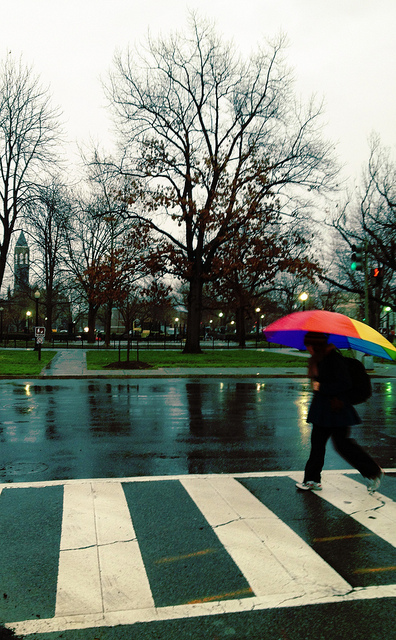<image>What intersection is this crosswalk at? It is unknown what intersection this crosswalk is at. It could be at Pennsylvania, at a park, or 10th Avenue. What intersection is this crosswalk at? It is unclear what intersection this crosswalk is at. There are multiple possibilities such as Pennsylvania, Square, 10th Ave, and Parkway. 